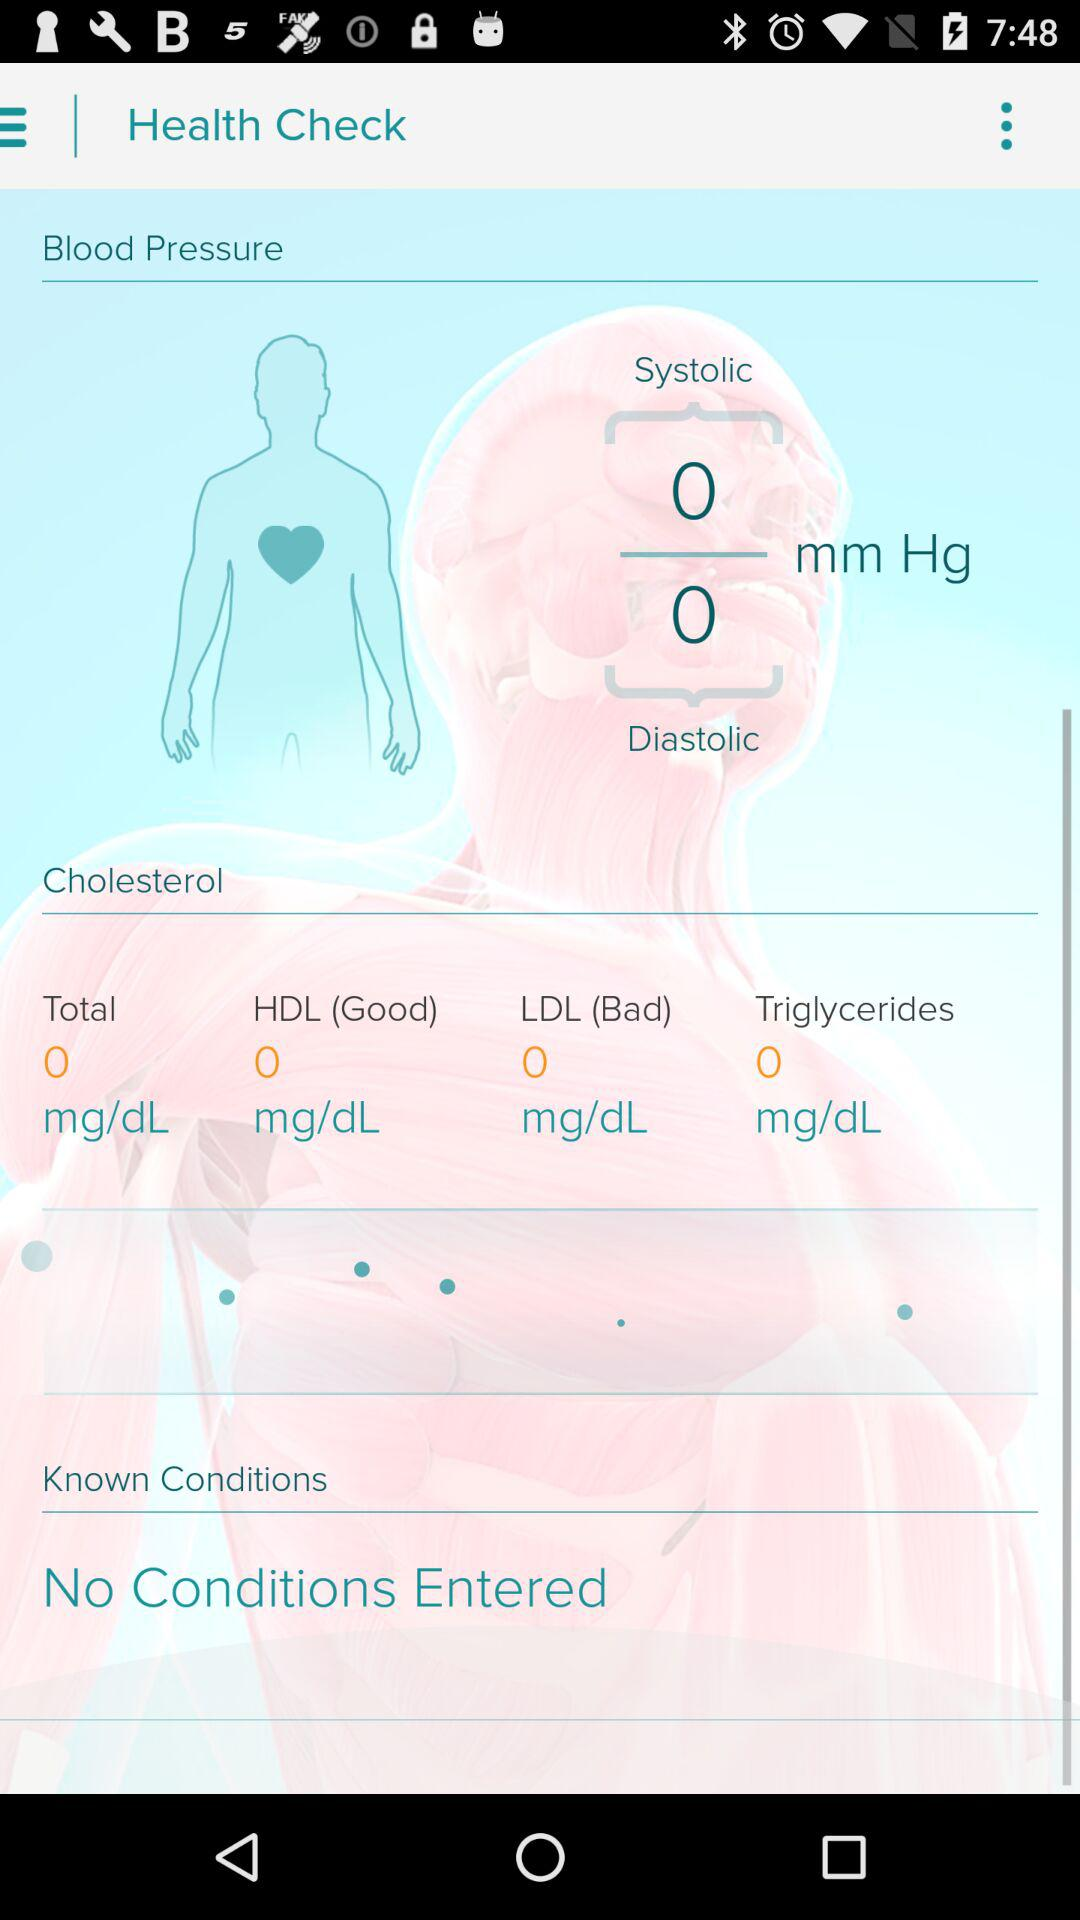What are the categories of cholesterol? The categories of cholesterol are "HDL" and "LDL". 